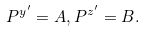<formula> <loc_0><loc_0><loc_500><loc_500>P ^ { y ^ { \prime } } = A , P ^ { z ^ { \prime } } = B . \,</formula> 